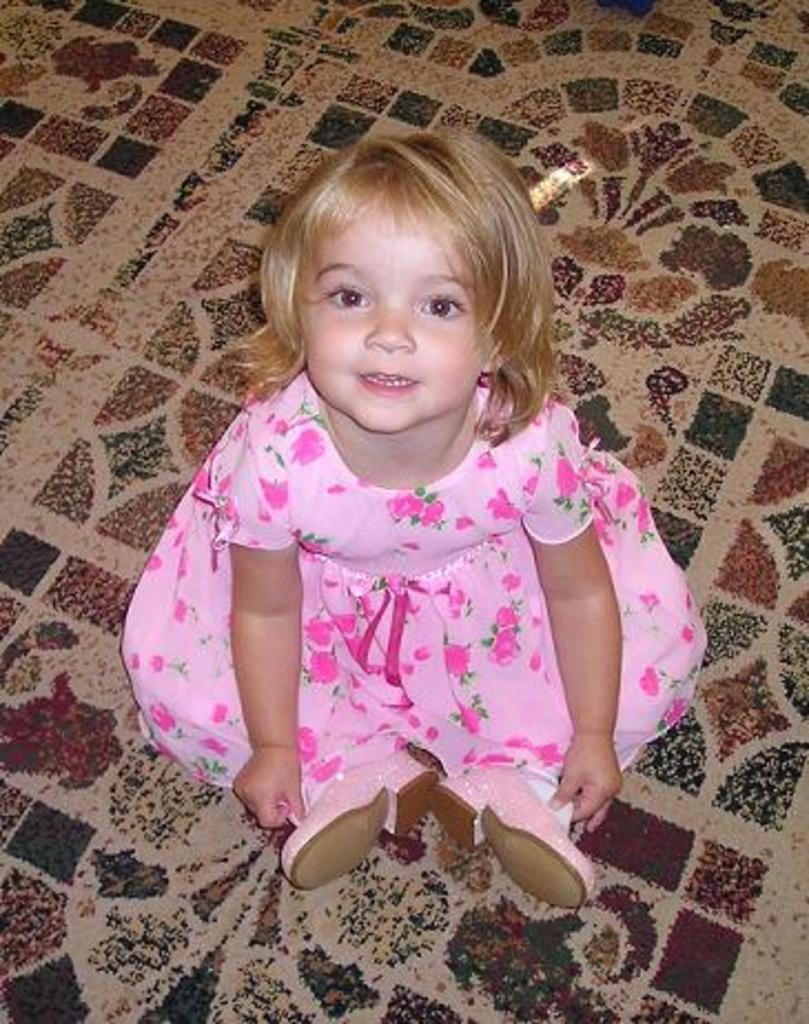What is the main subject of the picture? The main subject of the picture is a kid. What is the kid doing in the picture? The kid is sitting on the floor. What is the kid wearing in the picture? The kid is wearing a pink dress and shoes. What is the kid's breath like in the picture? There is no information about the kid's breath in the picture, as it is a still image and does not capture any sounds or movements. 